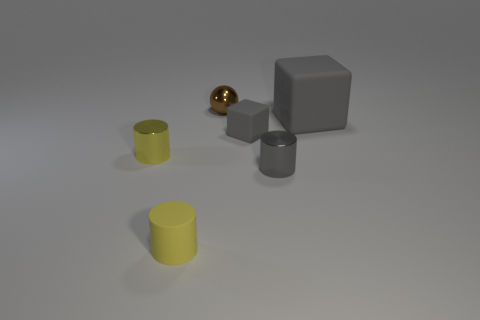Add 2 small matte cylinders. How many objects exist? 8 Subtract all blocks. How many objects are left? 4 Subtract 0 cyan cylinders. How many objects are left? 6 Subtract all gray metallic things. Subtract all tiny gray shiny cylinders. How many objects are left? 4 Add 2 matte cylinders. How many matte cylinders are left? 3 Add 1 tiny brown objects. How many tiny brown objects exist? 2 